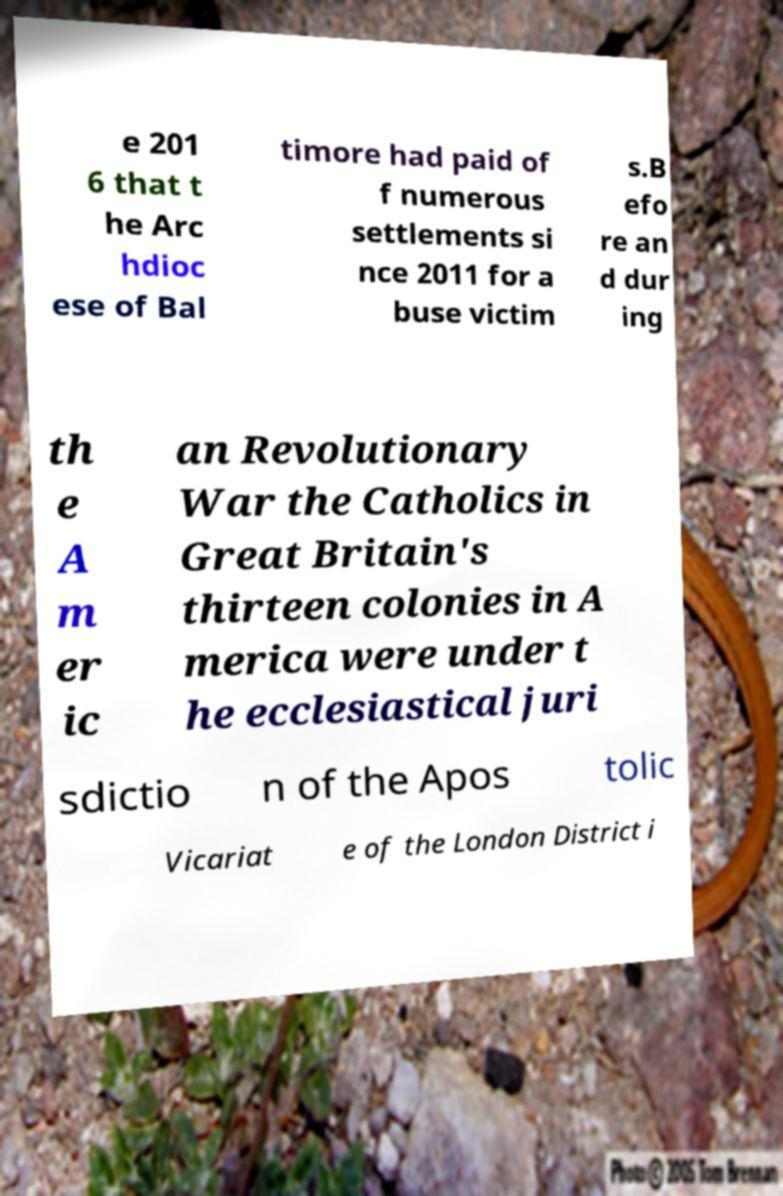There's text embedded in this image that I need extracted. Can you transcribe it verbatim? e 201 6 that t he Arc hdioc ese of Bal timore had paid of f numerous settlements si nce 2011 for a buse victim s.B efo re an d dur ing th e A m er ic an Revolutionary War the Catholics in Great Britain's thirteen colonies in A merica were under t he ecclesiastical juri sdictio n of the Apos tolic Vicariat e of the London District i 